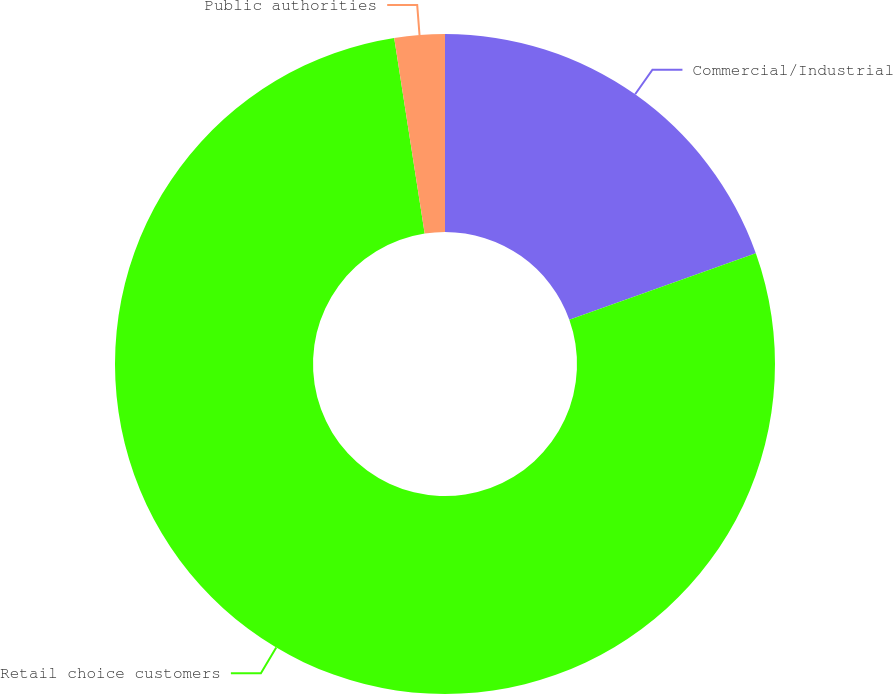<chart> <loc_0><loc_0><loc_500><loc_500><pie_chart><fcel>Commercial/Industrial<fcel>Retail choice customers<fcel>Public authorities<nl><fcel>19.55%<fcel>78.0%<fcel>2.46%<nl></chart> 